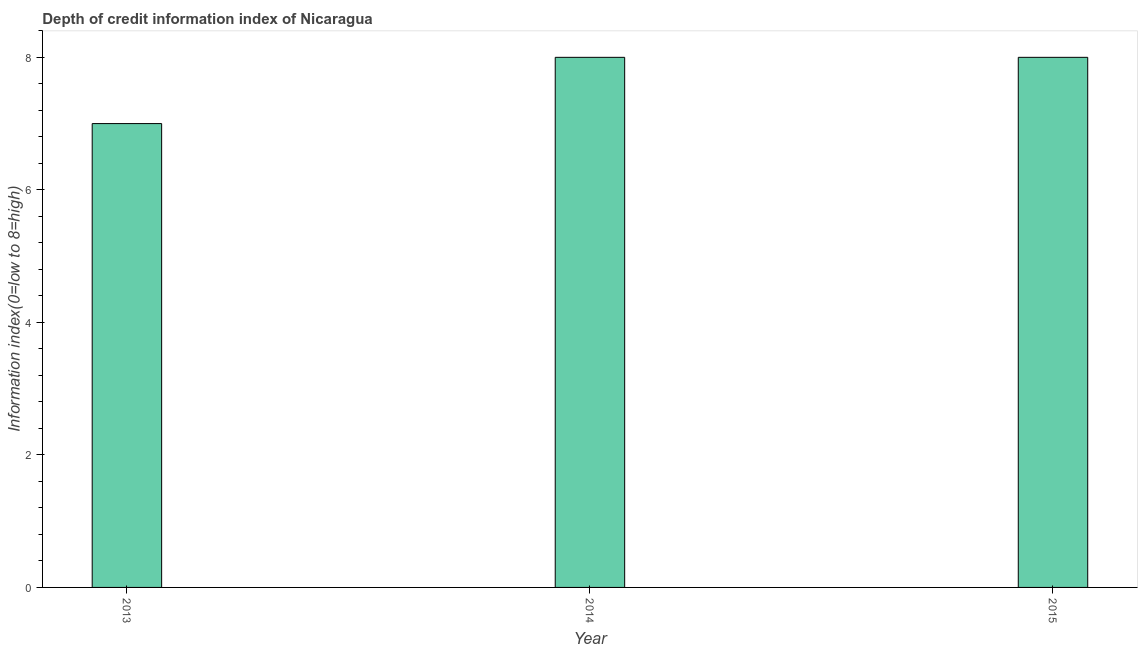Does the graph contain grids?
Your answer should be very brief. No. What is the title of the graph?
Provide a short and direct response. Depth of credit information index of Nicaragua. What is the label or title of the X-axis?
Make the answer very short. Year. What is the label or title of the Y-axis?
Keep it short and to the point. Information index(0=low to 8=high). What is the depth of credit information index in 2013?
Offer a very short reply. 7. Across all years, what is the maximum depth of credit information index?
Ensure brevity in your answer.  8. Across all years, what is the minimum depth of credit information index?
Provide a succinct answer. 7. What is the average depth of credit information index per year?
Your answer should be very brief. 7. What is the median depth of credit information index?
Your answer should be very brief. 8. In how many years, is the depth of credit information index greater than 4.4 ?
Your answer should be compact. 3. Do a majority of the years between 2015 and 2014 (inclusive) have depth of credit information index greater than 4.8 ?
Offer a very short reply. No. What is the ratio of the depth of credit information index in 2014 to that in 2015?
Keep it short and to the point. 1. Is the depth of credit information index in 2014 less than that in 2015?
Provide a short and direct response. No. Is the difference between the depth of credit information index in 2013 and 2014 greater than the difference between any two years?
Your answer should be compact. Yes. Is the sum of the depth of credit information index in 2014 and 2015 greater than the maximum depth of credit information index across all years?
Provide a short and direct response. Yes. What is the difference between the highest and the lowest depth of credit information index?
Provide a short and direct response. 1. What is the Information index(0=low to 8=high) in 2013?
Offer a very short reply. 7. What is the Information index(0=low to 8=high) of 2014?
Your answer should be compact. 8. What is the Information index(0=low to 8=high) of 2015?
Keep it short and to the point. 8. What is the difference between the Information index(0=low to 8=high) in 2013 and 2014?
Provide a short and direct response. -1. What is the difference between the Information index(0=low to 8=high) in 2013 and 2015?
Your answer should be compact. -1. What is the difference between the Information index(0=low to 8=high) in 2014 and 2015?
Your answer should be compact. 0. What is the ratio of the Information index(0=low to 8=high) in 2013 to that in 2014?
Provide a succinct answer. 0.88. What is the ratio of the Information index(0=low to 8=high) in 2013 to that in 2015?
Provide a succinct answer. 0.88. What is the ratio of the Information index(0=low to 8=high) in 2014 to that in 2015?
Give a very brief answer. 1. 